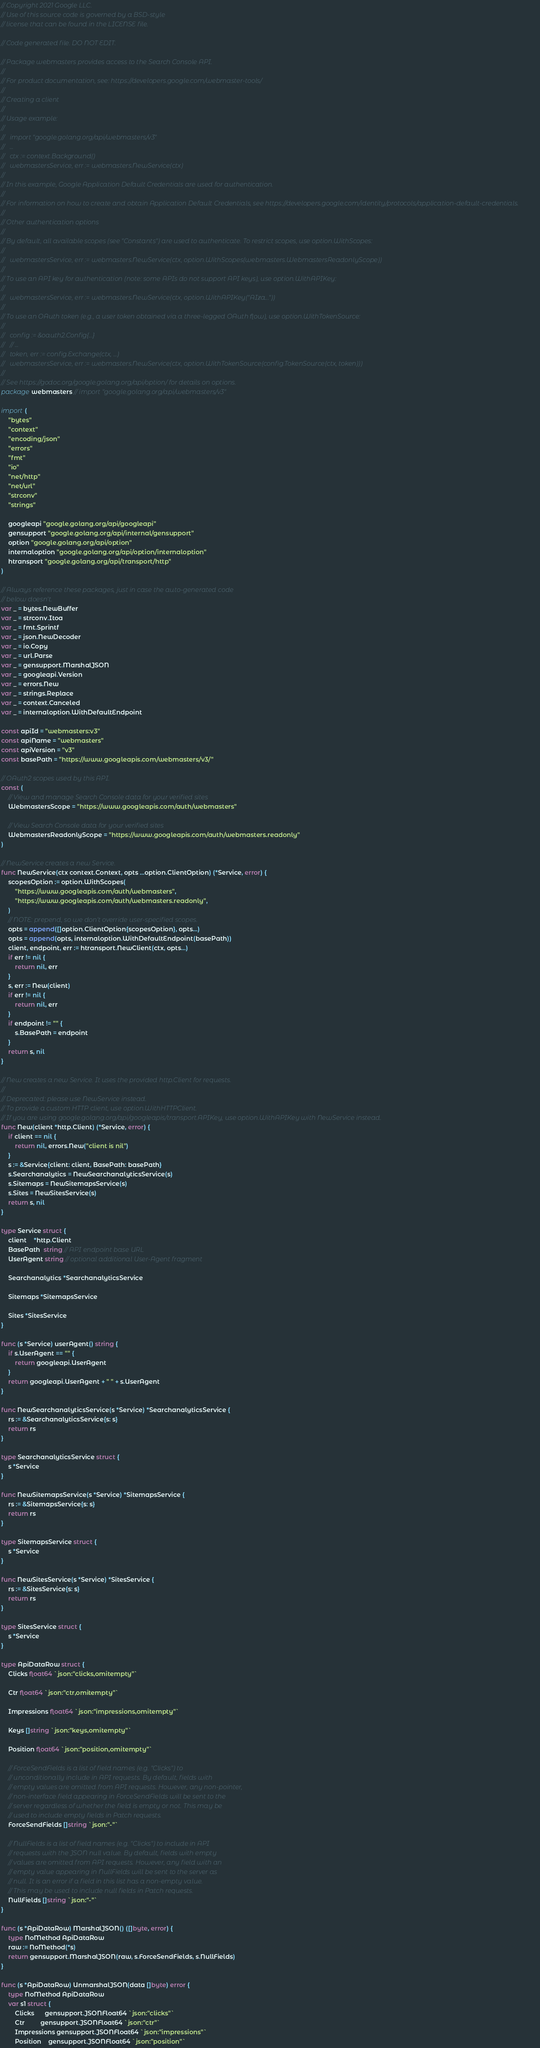<code> <loc_0><loc_0><loc_500><loc_500><_Go_>// Copyright 2021 Google LLC.
// Use of this source code is governed by a BSD-style
// license that can be found in the LICENSE file.

// Code generated file. DO NOT EDIT.

// Package webmasters provides access to the Search Console API.
//
// For product documentation, see: https://developers.google.com/webmaster-tools/
//
// Creating a client
//
// Usage example:
//
//   import "google.golang.org/api/webmasters/v3"
//   ...
//   ctx := context.Background()
//   webmastersService, err := webmasters.NewService(ctx)
//
// In this example, Google Application Default Credentials are used for authentication.
//
// For information on how to create and obtain Application Default Credentials, see https://developers.google.com/identity/protocols/application-default-credentials.
//
// Other authentication options
//
// By default, all available scopes (see "Constants") are used to authenticate. To restrict scopes, use option.WithScopes:
//
//   webmastersService, err := webmasters.NewService(ctx, option.WithScopes(webmasters.WebmastersReadonlyScope))
//
// To use an API key for authentication (note: some APIs do not support API keys), use option.WithAPIKey:
//
//   webmastersService, err := webmasters.NewService(ctx, option.WithAPIKey("AIza..."))
//
// To use an OAuth token (e.g., a user token obtained via a three-legged OAuth flow), use option.WithTokenSource:
//
//   config := &oauth2.Config{...}
//   // ...
//   token, err := config.Exchange(ctx, ...)
//   webmastersService, err := webmasters.NewService(ctx, option.WithTokenSource(config.TokenSource(ctx, token)))
//
// See https://godoc.org/google.golang.org/api/option/ for details on options.
package webmasters // import "google.golang.org/api/webmasters/v3"

import (
	"bytes"
	"context"
	"encoding/json"
	"errors"
	"fmt"
	"io"
	"net/http"
	"net/url"
	"strconv"
	"strings"

	googleapi "google.golang.org/api/googleapi"
	gensupport "google.golang.org/api/internal/gensupport"
	option "google.golang.org/api/option"
	internaloption "google.golang.org/api/option/internaloption"
	htransport "google.golang.org/api/transport/http"
)

// Always reference these packages, just in case the auto-generated code
// below doesn't.
var _ = bytes.NewBuffer
var _ = strconv.Itoa
var _ = fmt.Sprintf
var _ = json.NewDecoder
var _ = io.Copy
var _ = url.Parse
var _ = gensupport.MarshalJSON
var _ = googleapi.Version
var _ = errors.New
var _ = strings.Replace
var _ = context.Canceled
var _ = internaloption.WithDefaultEndpoint

const apiId = "webmasters:v3"
const apiName = "webmasters"
const apiVersion = "v3"
const basePath = "https://www.googleapis.com/webmasters/v3/"

// OAuth2 scopes used by this API.
const (
	// View and manage Search Console data for your verified sites
	WebmastersScope = "https://www.googleapis.com/auth/webmasters"

	// View Search Console data for your verified sites
	WebmastersReadonlyScope = "https://www.googleapis.com/auth/webmasters.readonly"
)

// NewService creates a new Service.
func NewService(ctx context.Context, opts ...option.ClientOption) (*Service, error) {
	scopesOption := option.WithScopes(
		"https://www.googleapis.com/auth/webmasters",
		"https://www.googleapis.com/auth/webmasters.readonly",
	)
	// NOTE: prepend, so we don't override user-specified scopes.
	opts = append([]option.ClientOption{scopesOption}, opts...)
	opts = append(opts, internaloption.WithDefaultEndpoint(basePath))
	client, endpoint, err := htransport.NewClient(ctx, opts...)
	if err != nil {
		return nil, err
	}
	s, err := New(client)
	if err != nil {
		return nil, err
	}
	if endpoint != "" {
		s.BasePath = endpoint
	}
	return s, nil
}

// New creates a new Service. It uses the provided http.Client for requests.
//
// Deprecated: please use NewService instead.
// To provide a custom HTTP client, use option.WithHTTPClient.
// If you are using google.golang.org/api/googleapis/transport.APIKey, use option.WithAPIKey with NewService instead.
func New(client *http.Client) (*Service, error) {
	if client == nil {
		return nil, errors.New("client is nil")
	}
	s := &Service{client: client, BasePath: basePath}
	s.Searchanalytics = NewSearchanalyticsService(s)
	s.Sitemaps = NewSitemapsService(s)
	s.Sites = NewSitesService(s)
	return s, nil
}

type Service struct {
	client    *http.Client
	BasePath  string // API endpoint base URL
	UserAgent string // optional additional User-Agent fragment

	Searchanalytics *SearchanalyticsService

	Sitemaps *SitemapsService

	Sites *SitesService
}

func (s *Service) userAgent() string {
	if s.UserAgent == "" {
		return googleapi.UserAgent
	}
	return googleapi.UserAgent + " " + s.UserAgent
}

func NewSearchanalyticsService(s *Service) *SearchanalyticsService {
	rs := &SearchanalyticsService{s: s}
	return rs
}

type SearchanalyticsService struct {
	s *Service
}

func NewSitemapsService(s *Service) *SitemapsService {
	rs := &SitemapsService{s: s}
	return rs
}

type SitemapsService struct {
	s *Service
}

func NewSitesService(s *Service) *SitesService {
	rs := &SitesService{s: s}
	return rs
}

type SitesService struct {
	s *Service
}

type ApiDataRow struct {
	Clicks float64 `json:"clicks,omitempty"`

	Ctr float64 `json:"ctr,omitempty"`

	Impressions float64 `json:"impressions,omitempty"`

	Keys []string `json:"keys,omitempty"`

	Position float64 `json:"position,omitempty"`

	// ForceSendFields is a list of field names (e.g. "Clicks") to
	// unconditionally include in API requests. By default, fields with
	// empty values are omitted from API requests. However, any non-pointer,
	// non-interface field appearing in ForceSendFields will be sent to the
	// server regardless of whether the field is empty or not. This may be
	// used to include empty fields in Patch requests.
	ForceSendFields []string `json:"-"`

	// NullFields is a list of field names (e.g. "Clicks") to include in API
	// requests with the JSON null value. By default, fields with empty
	// values are omitted from API requests. However, any field with an
	// empty value appearing in NullFields will be sent to the server as
	// null. It is an error if a field in this list has a non-empty value.
	// This may be used to include null fields in Patch requests.
	NullFields []string `json:"-"`
}

func (s *ApiDataRow) MarshalJSON() ([]byte, error) {
	type NoMethod ApiDataRow
	raw := NoMethod(*s)
	return gensupport.MarshalJSON(raw, s.ForceSendFields, s.NullFields)
}

func (s *ApiDataRow) UnmarshalJSON(data []byte) error {
	type NoMethod ApiDataRow
	var s1 struct {
		Clicks      gensupport.JSONFloat64 `json:"clicks"`
		Ctr         gensupport.JSONFloat64 `json:"ctr"`
		Impressions gensupport.JSONFloat64 `json:"impressions"`
		Position    gensupport.JSONFloat64 `json:"position"`</code> 